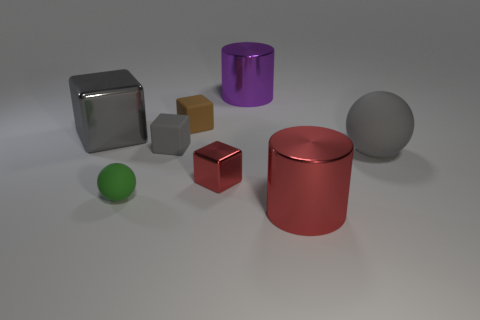Is the material of the tiny cube that is in front of the big gray matte ball the same as the big sphere?
Provide a succinct answer. No. What material is the large gray object that is to the left of the large metallic cylinder behind the big metallic cylinder that is in front of the gray rubber cube made of?
Provide a succinct answer. Metal. Is there anything else that has the same size as the green rubber object?
Ensure brevity in your answer.  Yes. What number of matte objects are either brown spheres or big cylinders?
Make the answer very short. 0. Is there a small red shiny block?
Offer a terse response. Yes. What is the color of the ball to the left of the big metal cylinder that is behind the big matte ball?
Make the answer very short. Green. How many other things are the same color as the tiny metal thing?
Provide a short and direct response. 1. What number of things are either gray spheres or cubes to the left of the red cube?
Your answer should be very brief. 4. There is a ball in front of the large matte object; what color is it?
Make the answer very short. Green. What is the shape of the green matte thing?
Provide a succinct answer. Sphere. 